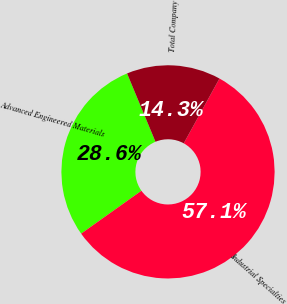Convert chart. <chart><loc_0><loc_0><loc_500><loc_500><pie_chart><fcel>Advanced Engineered Materials<fcel>Industrial Specialties<fcel>Total Company<nl><fcel>28.57%<fcel>57.14%<fcel>14.29%<nl></chart> 